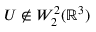Convert formula to latex. <formula><loc_0><loc_0><loc_500><loc_500>U \not \in W _ { 2 } ^ { 2 } ( { \mathbb { R } } ^ { 3 } )</formula> 